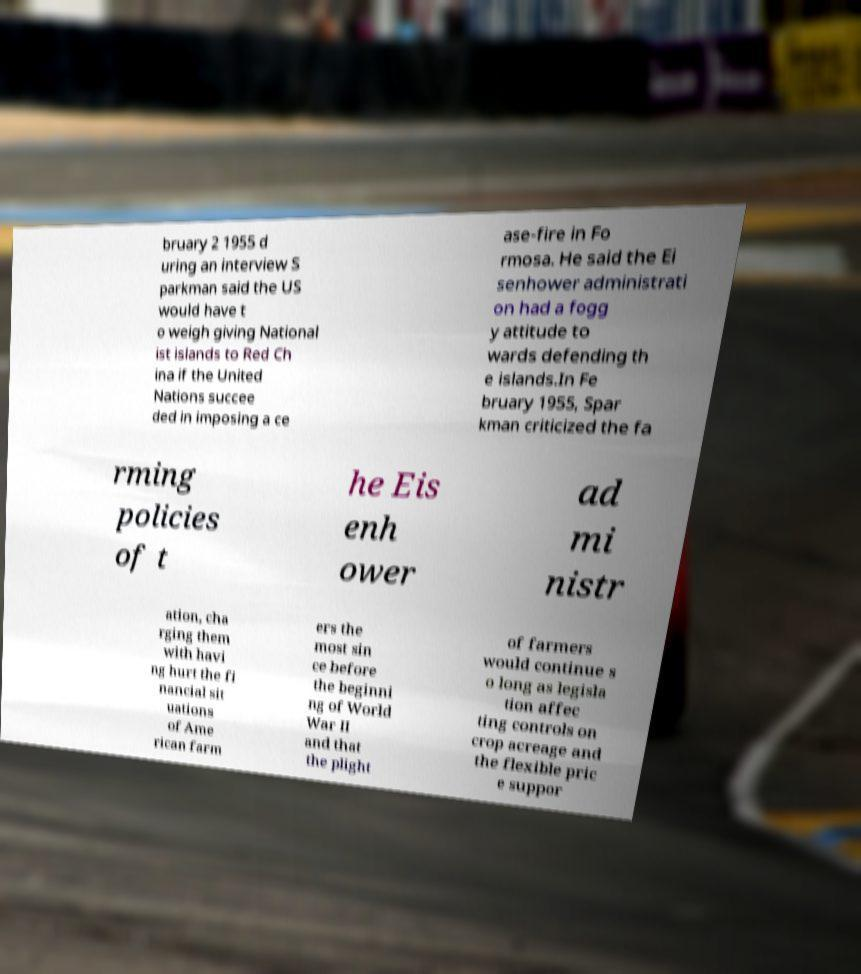What messages or text are displayed in this image? I need them in a readable, typed format. bruary 2 1955 d uring an interview S parkman said the US would have t o weigh giving National ist islands to Red Ch ina if the United Nations succee ded in imposing a ce ase-fire in Fo rmosa. He said the Ei senhower administrati on had a fogg y attitude to wards defending th e islands.In Fe bruary 1955, Spar kman criticized the fa rming policies of t he Eis enh ower ad mi nistr ation, cha rging them with havi ng hurt the fi nancial sit uations of Ame rican farm ers the most sin ce before the beginni ng of World War II and that the plight of farmers would continue s o long as legisla tion affec ting controls on crop acreage and the flexible pric e suppor 